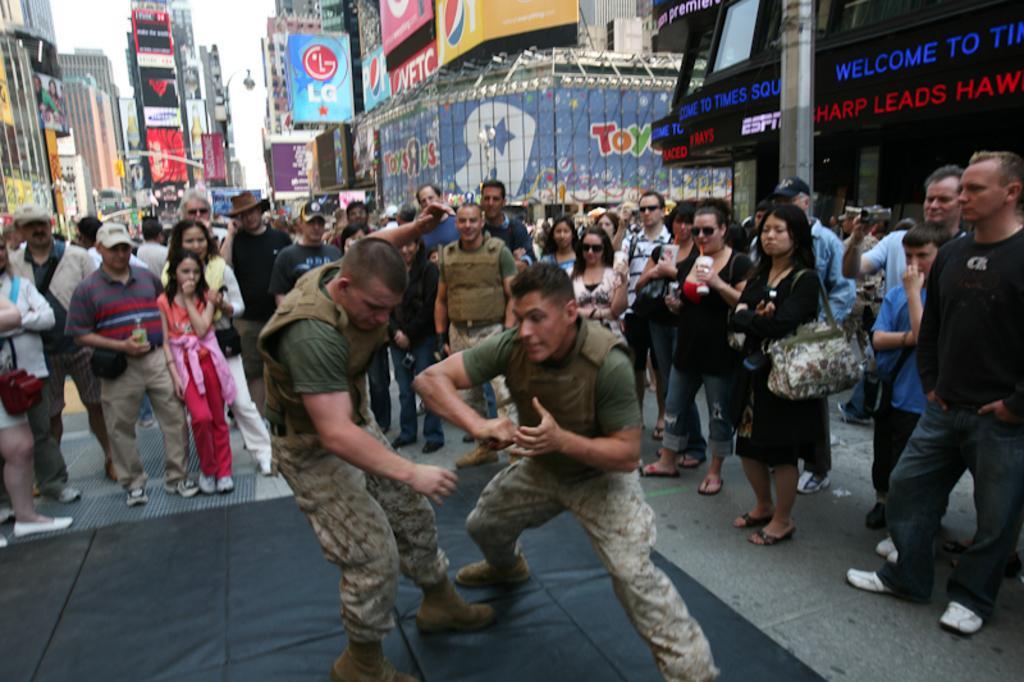Can you describe this image briefly? In this picture we can see a group of people standing on the road and in the background we can see buildings, banners, sky. 